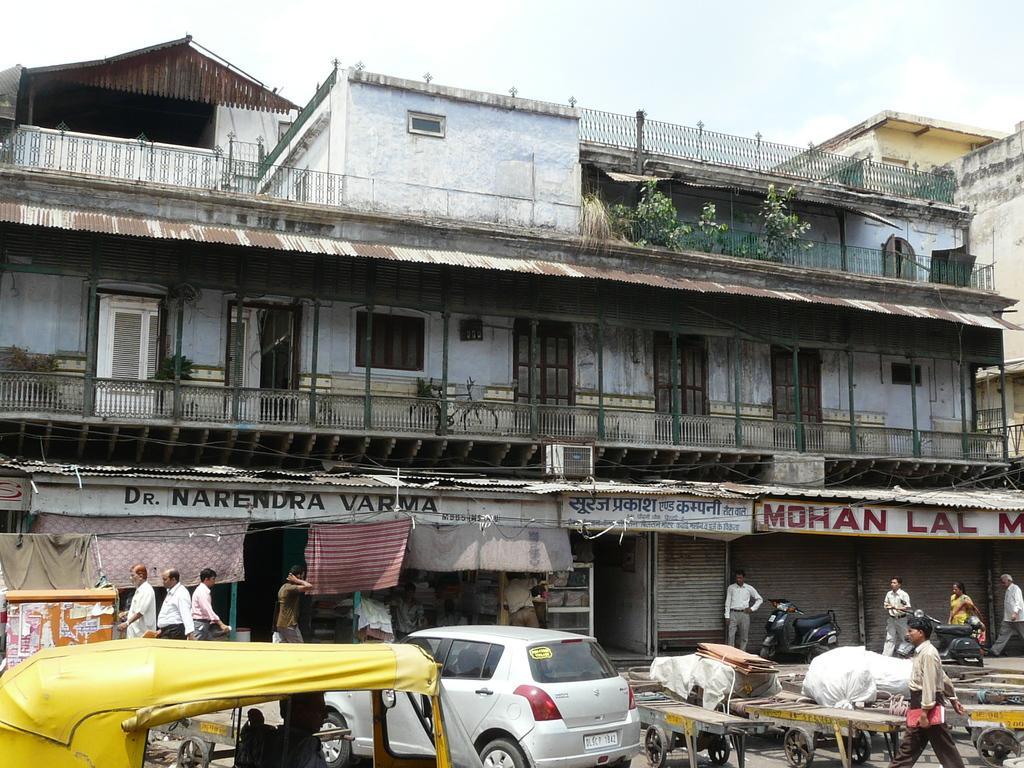How would you summarize this image in a sentence or two? At the bottom of the image there are vehicles and also there are carts. And there are few objects on the carts. And there is a person standing and holding an object in his hand. Behind those vehicles on the footpath there are few people and also there is a box on the left side. In the background there is a building with walls, windows, doors, railings and plants. And also there are stores with name boards and some other things. 